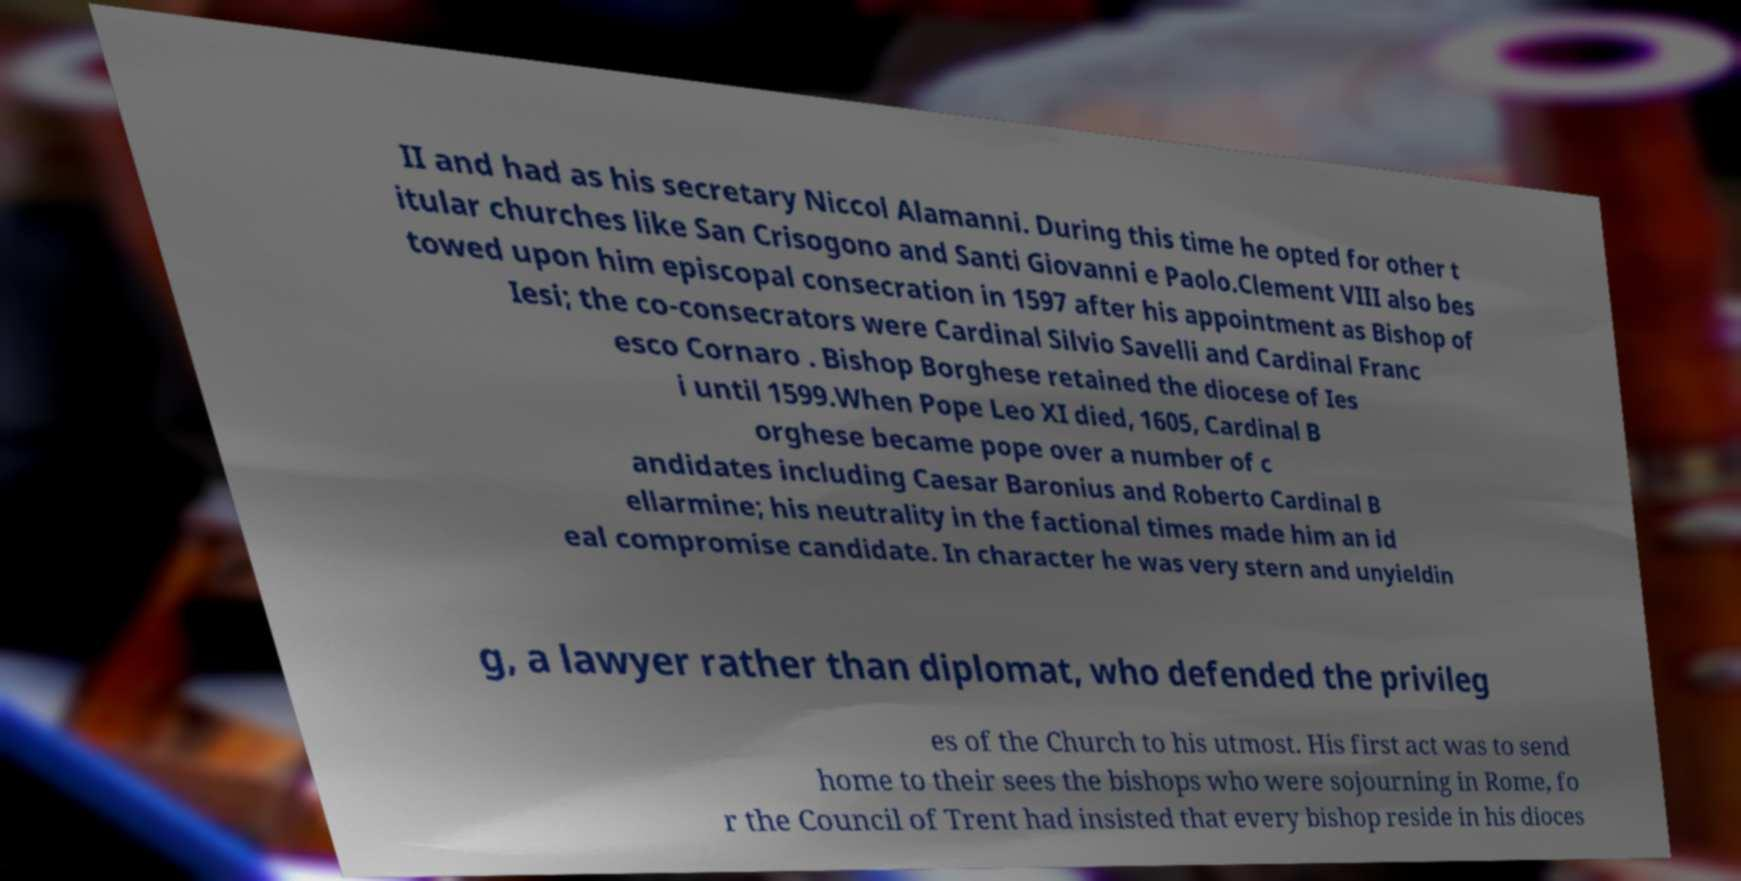Could you assist in decoding the text presented in this image and type it out clearly? II and had as his secretary Niccol Alamanni. During this time he opted for other t itular churches like San Crisogono and Santi Giovanni e Paolo.Clement VIII also bes towed upon him episcopal consecration in 1597 after his appointment as Bishop of Iesi; the co-consecrators were Cardinal Silvio Savelli and Cardinal Franc esco Cornaro . Bishop Borghese retained the diocese of Ies i until 1599.When Pope Leo XI died, 1605, Cardinal B orghese became pope over a number of c andidates including Caesar Baronius and Roberto Cardinal B ellarmine; his neutrality in the factional times made him an id eal compromise candidate. In character he was very stern and unyieldin g, a lawyer rather than diplomat, who defended the privileg es of the Church to his utmost. His first act was to send home to their sees the bishops who were sojourning in Rome, fo r the Council of Trent had insisted that every bishop reside in his dioces 